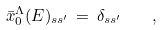Convert formula to latex. <formula><loc_0><loc_0><loc_500><loc_500>\bar { x } _ { 0 } ^ { \Lambda } ( E ) _ { s s ^ { \prime } } \, = \, \delta _ { s s ^ { \prime } } \quad ,</formula> 